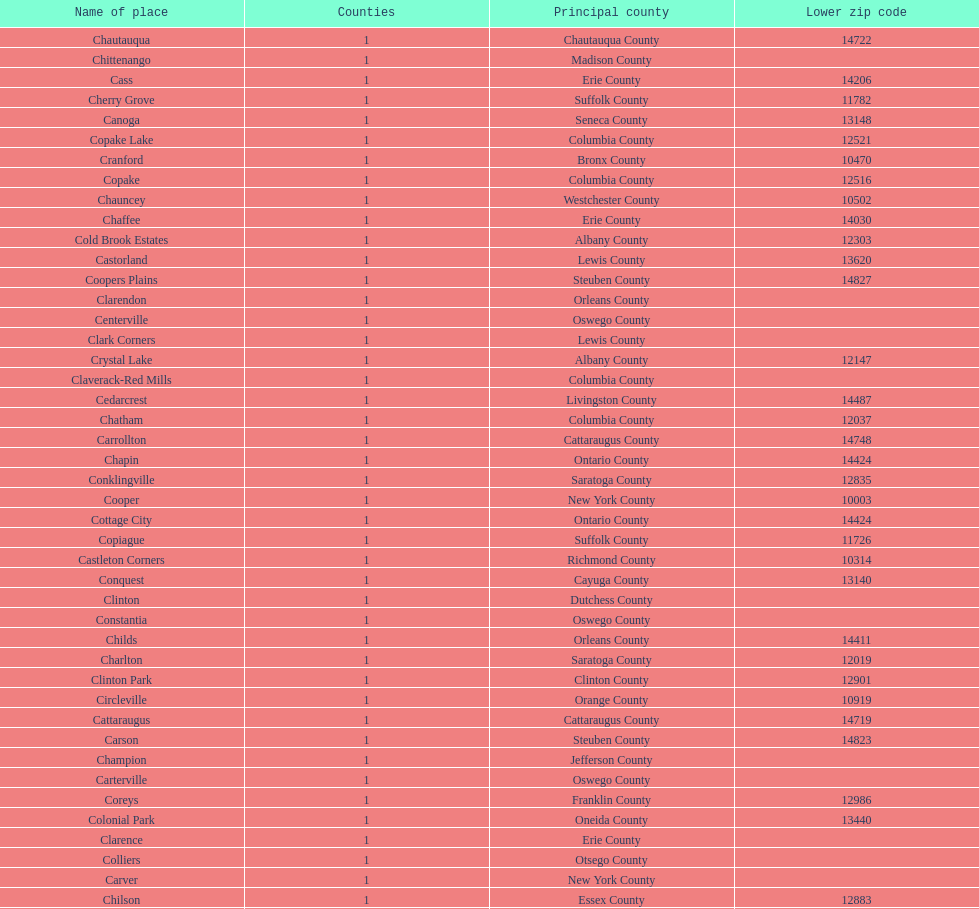Which place has the lowest, lower zip code? Cooper. 